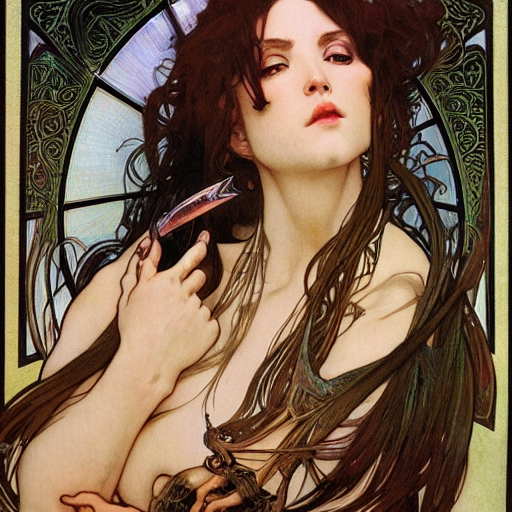Is the lighting sufficient? B. Yes, the image is well-lit, with the subject clearly illuminated to showcase the intricate details and colors of the artwork. The lighting appears intentionally styled to enhance the depth and mood of the scene, highlighting the subject's features and the delicate interplay of light and shadow. 